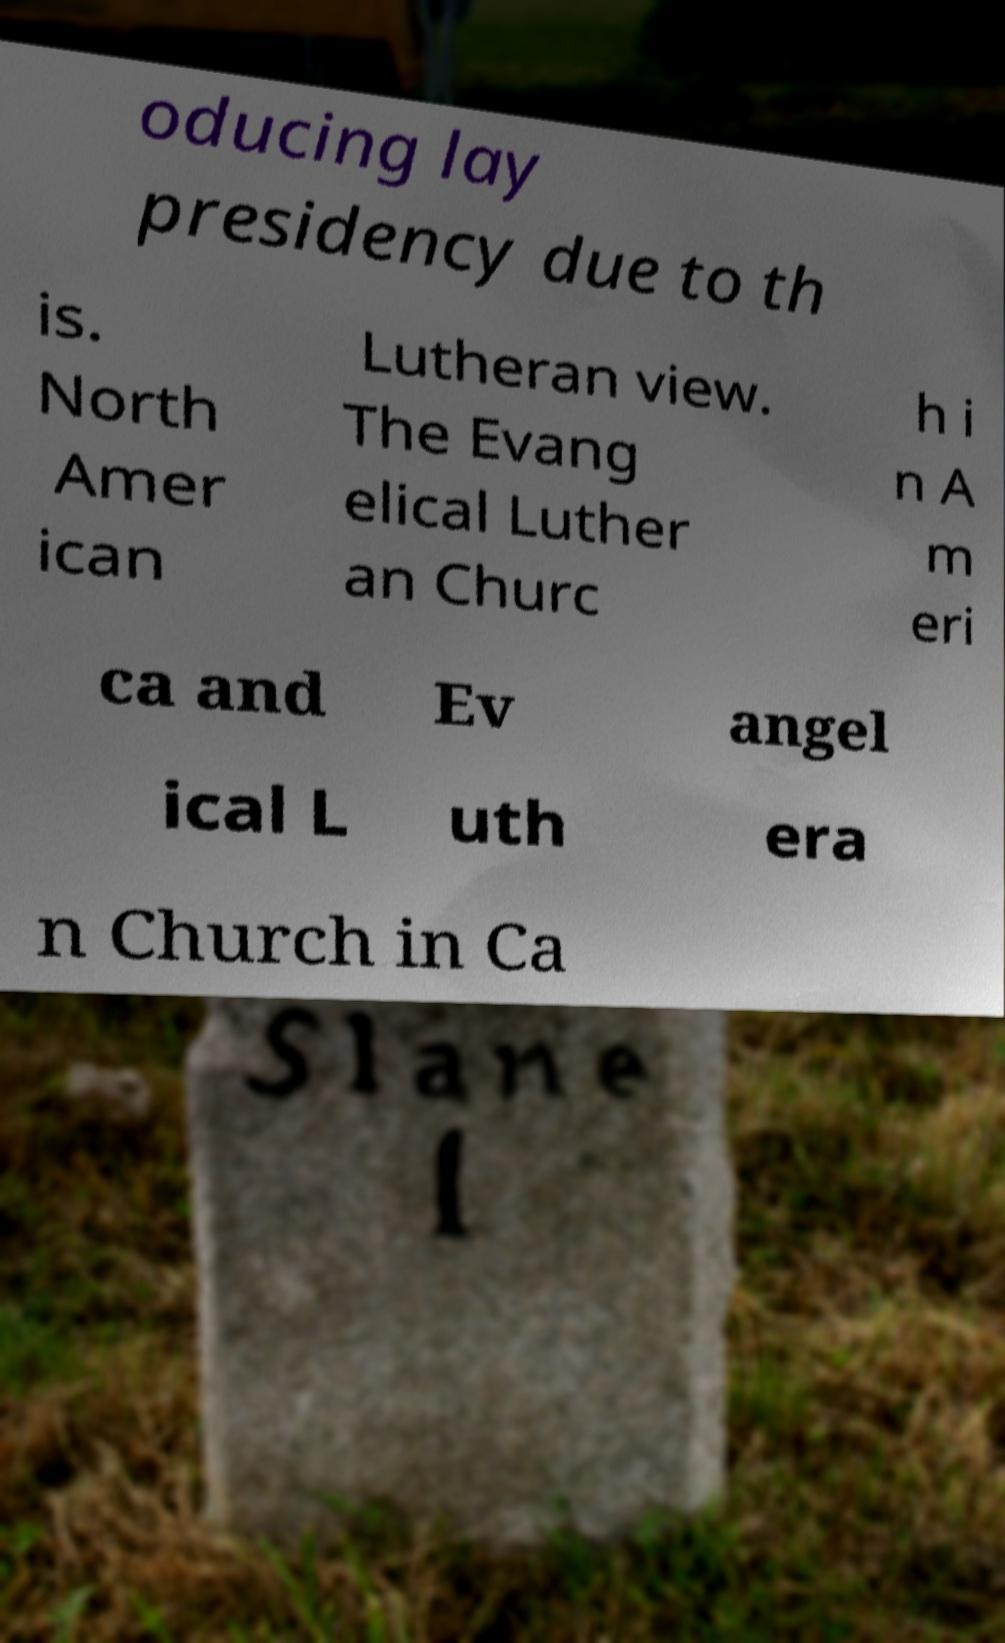Could you assist in decoding the text presented in this image and type it out clearly? oducing lay presidency due to th is. North Amer ican Lutheran view. The Evang elical Luther an Churc h i n A m eri ca and Ev angel ical L uth era n Church in Ca 